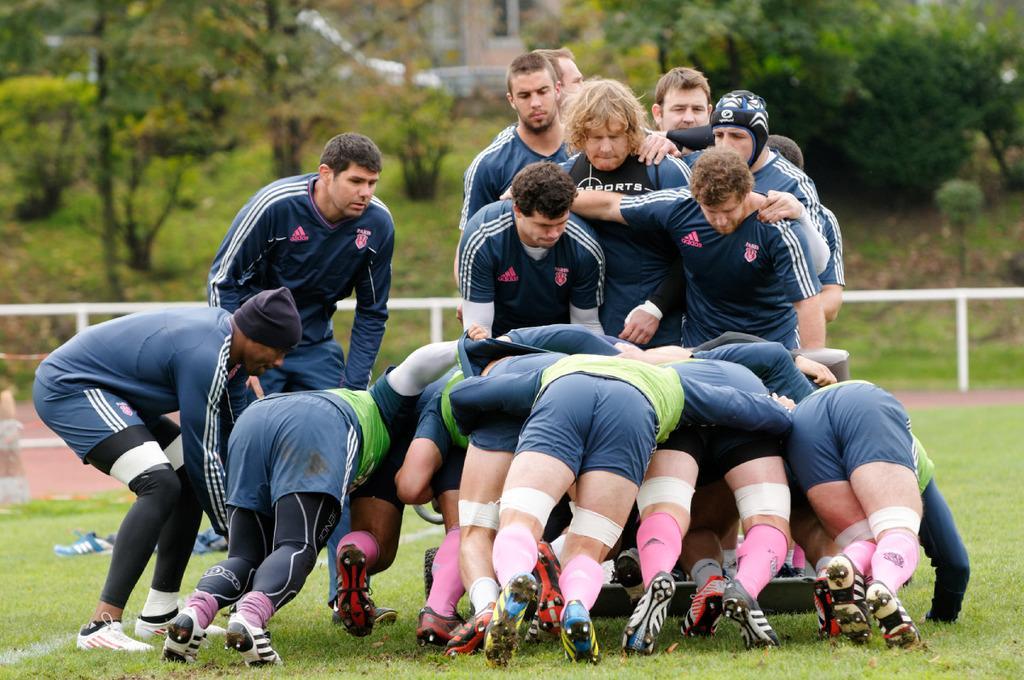Can you describe this image briefly? In this picture I can see there are some people standing here on the grass and there are some trees and there are building and the sky is clear. 